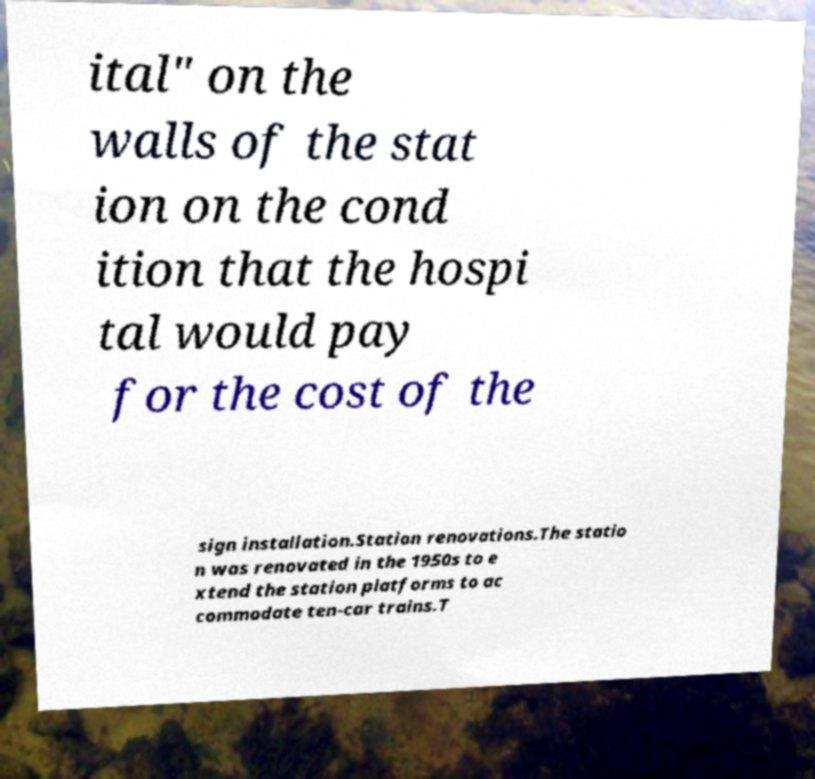There's text embedded in this image that I need extracted. Can you transcribe it verbatim? ital" on the walls of the stat ion on the cond ition that the hospi tal would pay for the cost of the sign installation.Station renovations.The statio n was renovated in the 1950s to e xtend the station platforms to ac commodate ten-car trains.T 